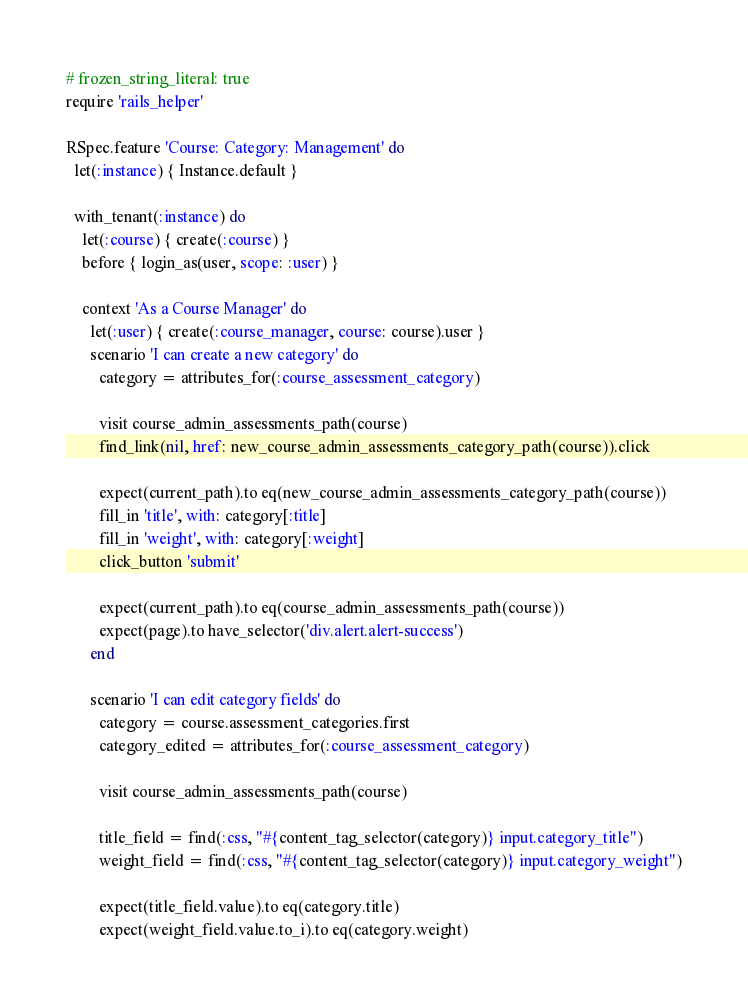Convert code to text. <code><loc_0><loc_0><loc_500><loc_500><_Ruby_># frozen_string_literal: true
require 'rails_helper'

RSpec.feature 'Course: Category: Management' do
  let(:instance) { Instance.default }

  with_tenant(:instance) do
    let(:course) { create(:course) }
    before { login_as(user, scope: :user) }

    context 'As a Course Manager' do
      let(:user) { create(:course_manager, course: course).user }
      scenario 'I can create a new category' do
        category = attributes_for(:course_assessment_category)

        visit course_admin_assessments_path(course)
        find_link(nil, href: new_course_admin_assessments_category_path(course)).click

        expect(current_path).to eq(new_course_admin_assessments_category_path(course))
        fill_in 'title', with: category[:title]
        fill_in 'weight', with: category[:weight]
        click_button 'submit'

        expect(current_path).to eq(course_admin_assessments_path(course))
        expect(page).to have_selector('div.alert.alert-success')
      end

      scenario 'I can edit category fields' do
        category = course.assessment_categories.first
        category_edited = attributes_for(:course_assessment_category)

        visit course_admin_assessments_path(course)

        title_field = find(:css, "#{content_tag_selector(category)} input.category_title")
        weight_field = find(:css, "#{content_tag_selector(category)} input.category_weight")

        expect(title_field.value).to eq(category.title)
        expect(weight_field.value.to_i).to eq(category.weight)
</code> 